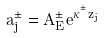Convert formula to latex. <formula><loc_0><loc_0><loc_500><loc_500>a _ { j } ^ { \pm } = A _ { E } ^ { \pm } e ^ { \kappa ^ { ^ { \pm } } z _ { j } }</formula> 